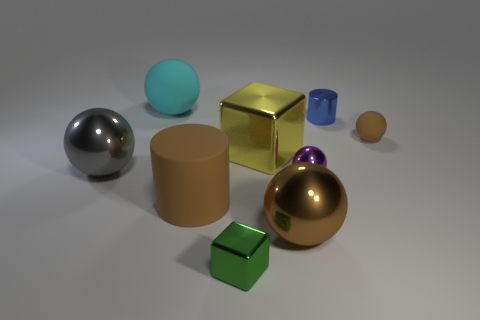Subtract all gray balls. How many balls are left? 4 Subtract all small metallic spheres. How many spheres are left? 4 Subtract all blue balls. Subtract all purple cubes. How many balls are left? 5 Add 1 large brown shiny balls. How many objects exist? 10 Subtract all cylinders. How many objects are left? 7 Subtract 0 red cylinders. How many objects are left? 9 Subtract all brown matte cylinders. Subtract all large brown cylinders. How many objects are left? 7 Add 1 brown cylinders. How many brown cylinders are left? 2 Add 3 tiny green balls. How many tiny green balls exist? 3 